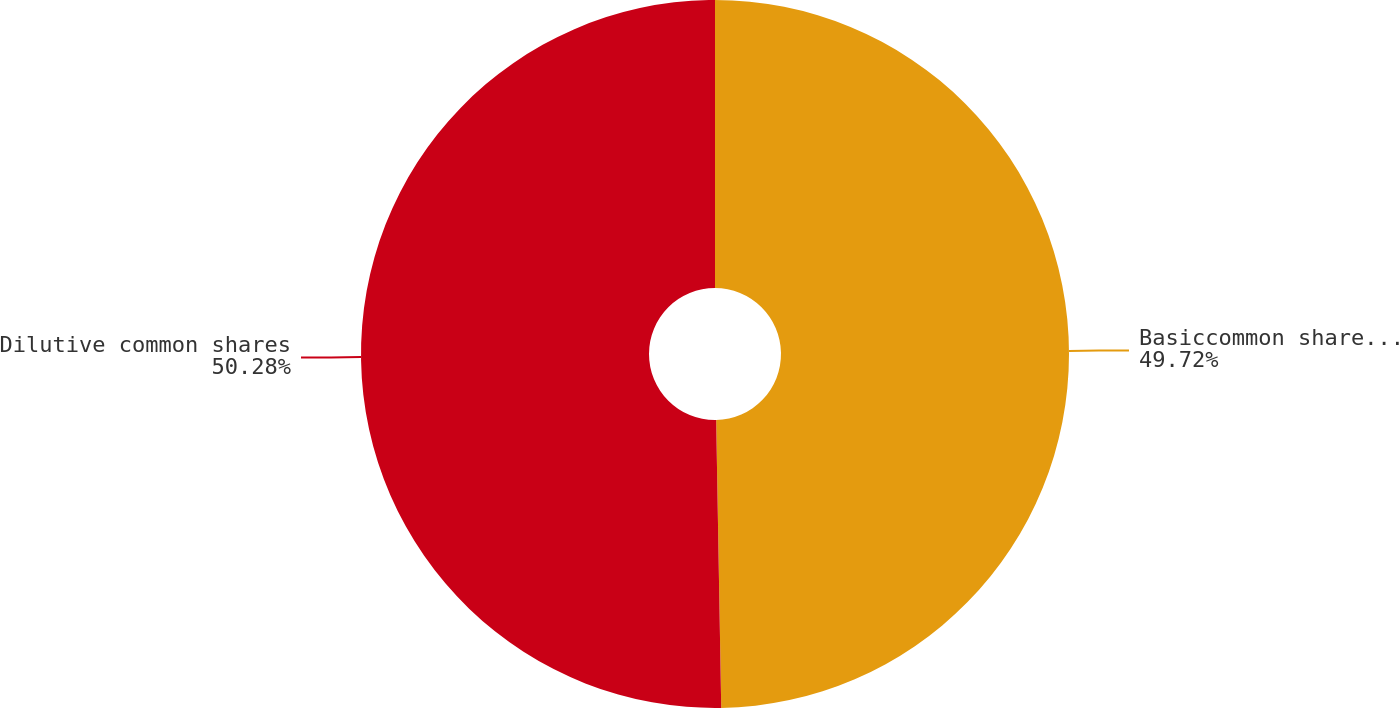Convert chart to OTSL. <chart><loc_0><loc_0><loc_500><loc_500><pie_chart><fcel>Basiccommon shares outstanding<fcel>Dilutive common shares<nl><fcel>49.72%<fcel>50.28%<nl></chart> 